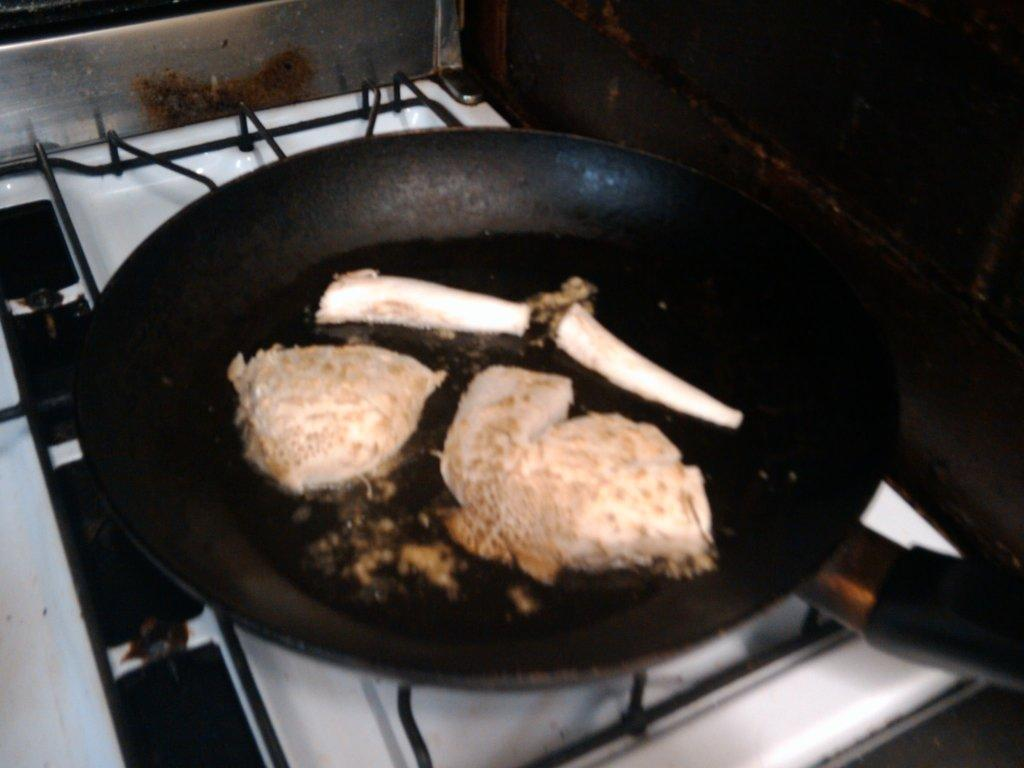What is happening to the food in the image? The food is cooking in the image. On what is the food cooking? The food is cooking on a pan. Where is the pan with the cooking food located? The pan is on a stove. What type of map can be seen hanging on the wall in the image? There is no map present in the image; it features food cooking on a pan on a stove. 